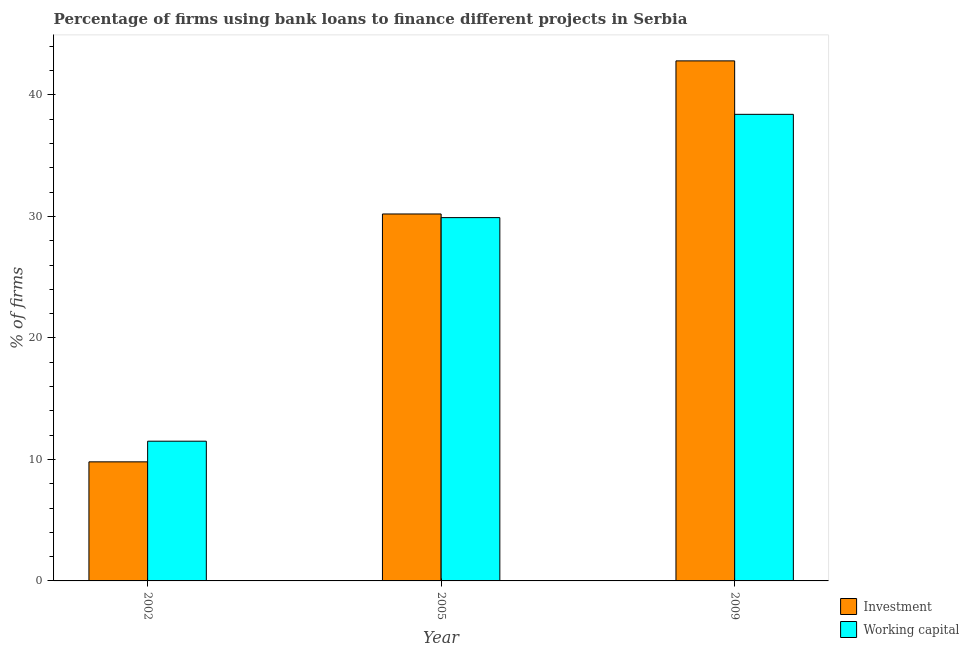How many different coloured bars are there?
Give a very brief answer. 2. Are the number of bars per tick equal to the number of legend labels?
Your answer should be very brief. Yes. Are the number of bars on each tick of the X-axis equal?
Give a very brief answer. Yes. In how many cases, is the number of bars for a given year not equal to the number of legend labels?
Your response must be concise. 0. What is the percentage of firms using banks to finance investment in 2009?
Offer a very short reply. 42.8. Across all years, what is the maximum percentage of firms using banks to finance investment?
Provide a succinct answer. 42.8. In which year was the percentage of firms using banks to finance investment maximum?
Your answer should be compact. 2009. What is the total percentage of firms using banks to finance investment in the graph?
Offer a very short reply. 82.8. What is the difference between the percentage of firms using banks to finance working capital in 2002 and that in 2005?
Your answer should be very brief. -18.4. What is the difference between the percentage of firms using banks to finance working capital in 2009 and the percentage of firms using banks to finance investment in 2002?
Provide a short and direct response. 26.9. What is the average percentage of firms using banks to finance investment per year?
Provide a succinct answer. 27.6. What is the ratio of the percentage of firms using banks to finance investment in 2002 to that in 2009?
Ensure brevity in your answer.  0.23. Is the percentage of firms using banks to finance investment in 2002 less than that in 2005?
Make the answer very short. Yes. Is the difference between the percentage of firms using banks to finance investment in 2002 and 2005 greater than the difference between the percentage of firms using banks to finance working capital in 2002 and 2005?
Give a very brief answer. No. What is the difference between the highest and the second highest percentage of firms using banks to finance investment?
Keep it short and to the point. 12.6. What is the difference between the highest and the lowest percentage of firms using banks to finance investment?
Offer a very short reply. 33. What does the 2nd bar from the left in 2005 represents?
Ensure brevity in your answer.  Working capital. What does the 2nd bar from the right in 2005 represents?
Give a very brief answer. Investment. How many years are there in the graph?
Your response must be concise. 3. What is the difference between two consecutive major ticks on the Y-axis?
Your answer should be compact. 10. Are the values on the major ticks of Y-axis written in scientific E-notation?
Ensure brevity in your answer.  No. Does the graph contain any zero values?
Keep it short and to the point. No. Where does the legend appear in the graph?
Ensure brevity in your answer.  Bottom right. How many legend labels are there?
Your answer should be very brief. 2. What is the title of the graph?
Ensure brevity in your answer.  Percentage of firms using bank loans to finance different projects in Serbia. What is the label or title of the Y-axis?
Make the answer very short. % of firms. What is the % of firms in Working capital in 2002?
Provide a short and direct response. 11.5. What is the % of firms of Investment in 2005?
Keep it short and to the point. 30.2. What is the % of firms in Working capital in 2005?
Your response must be concise. 29.9. What is the % of firms of Investment in 2009?
Ensure brevity in your answer.  42.8. What is the % of firms of Working capital in 2009?
Offer a terse response. 38.4. Across all years, what is the maximum % of firms in Investment?
Provide a succinct answer. 42.8. Across all years, what is the maximum % of firms of Working capital?
Provide a succinct answer. 38.4. Across all years, what is the minimum % of firms in Investment?
Provide a short and direct response. 9.8. Across all years, what is the minimum % of firms in Working capital?
Your answer should be compact. 11.5. What is the total % of firms of Investment in the graph?
Provide a short and direct response. 82.8. What is the total % of firms in Working capital in the graph?
Your answer should be very brief. 79.8. What is the difference between the % of firms of Investment in 2002 and that in 2005?
Make the answer very short. -20.4. What is the difference between the % of firms of Working capital in 2002 and that in 2005?
Provide a succinct answer. -18.4. What is the difference between the % of firms of Investment in 2002 and that in 2009?
Keep it short and to the point. -33. What is the difference between the % of firms of Working capital in 2002 and that in 2009?
Give a very brief answer. -26.9. What is the difference between the % of firms of Investment in 2005 and that in 2009?
Provide a succinct answer. -12.6. What is the difference between the % of firms in Investment in 2002 and the % of firms in Working capital in 2005?
Provide a short and direct response. -20.1. What is the difference between the % of firms of Investment in 2002 and the % of firms of Working capital in 2009?
Give a very brief answer. -28.6. What is the difference between the % of firms in Investment in 2005 and the % of firms in Working capital in 2009?
Give a very brief answer. -8.2. What is the average % of firms in Investment per year?
Ensure brevity in your answer.  27.6. What is the average % of firms of Working capital per year?
Your answer should be compact. 26.6. In the year 2002, what is the difference between the % of firms of Investment and % of firms of Working capital?
Your answer should be compact. -1.7. In the year 2005, what is the difference between the % of firms in Investment and % of firms in Working capital?
Your response must be concise. 0.3. In the year 2009, what is the difference between the % of firms of Investment and % of firms of Working capital?
Give a very brief answer. 4.4. What is the ratio of the % of firms in Investment in 2002 to that in 2005?
Provide a succinct answer. 0.32. What is the ratio of the % of firms of Working capital in 2002 to that in 2005?
Your response must be concise. 0.38. What is the ratio of the % of firms of Investment in 2002 to that in 2009?
Make the answer very short. 0.23. What is the ratio of the % of firms in Working capital in 2002 to that in 2009?
Provide a short and direct response. 0.3. What is the ratio of the % of firms of Investment in 2005 to that in 2009?
Offer a terse response. 0.71. What is the ratio of the % of firms in Working capital in 2005 to that in 2009?
Your answer should be very brief. 0.78. What is the difference between the highest and the second highest % of firms in Working capital?
Give a very brief answer. 8.5. What is the difference between the highest and the lowest % of firms of Working capital?
Ensure brevity in your answer.  26.9. 